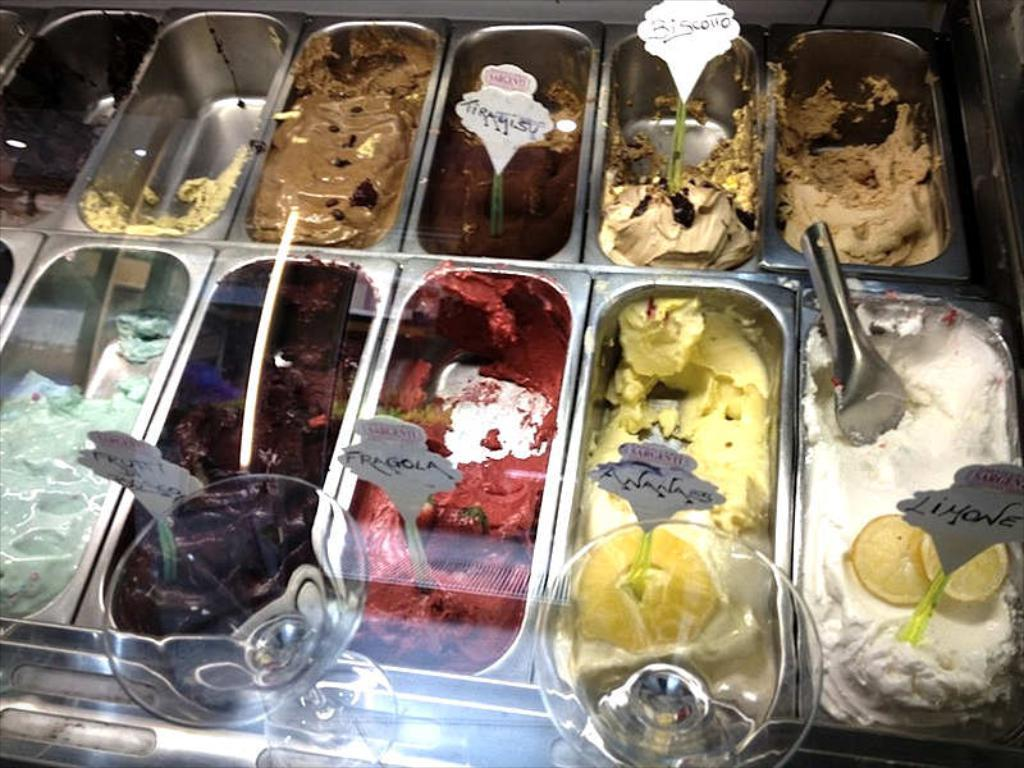What type of food is depicted in the image? There are ice cream pastes in the image. How are the ice cream pastes presented? The ice cream pastes are placed in bowls. What other object can be seen in the image? There is a glass visible at the bottom of the image. What type of clover is growing in the ice cream pastes? There is no clover present in the image; it features ice cream pastes in bowls and a glass. 